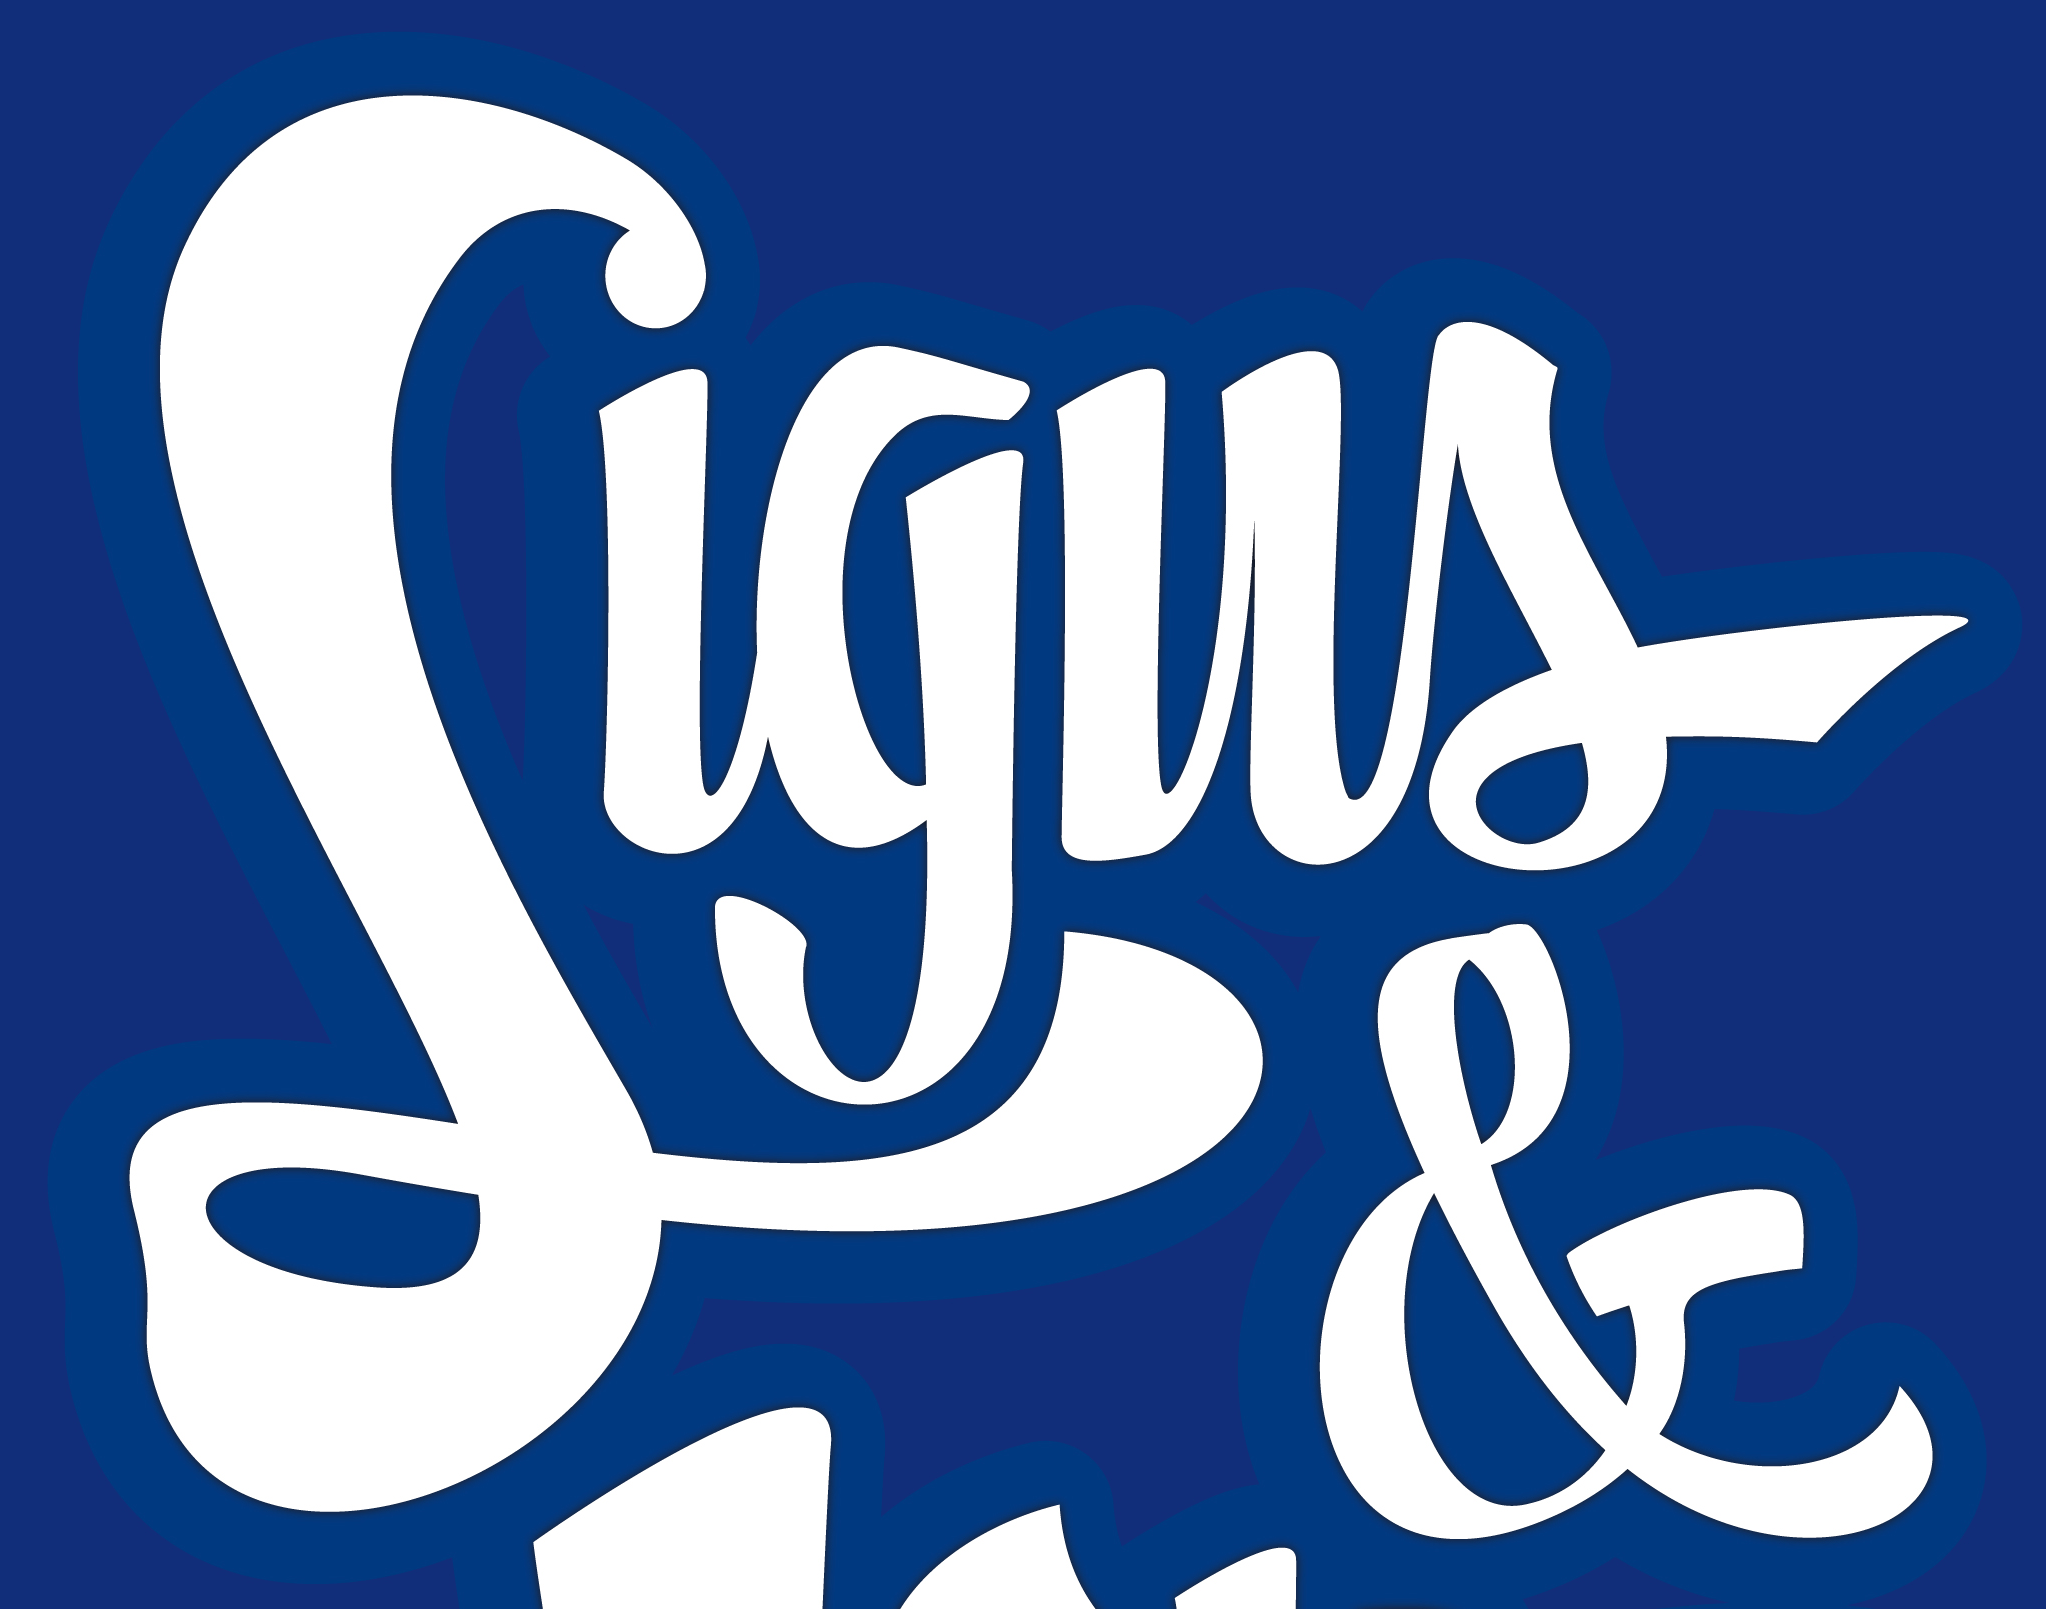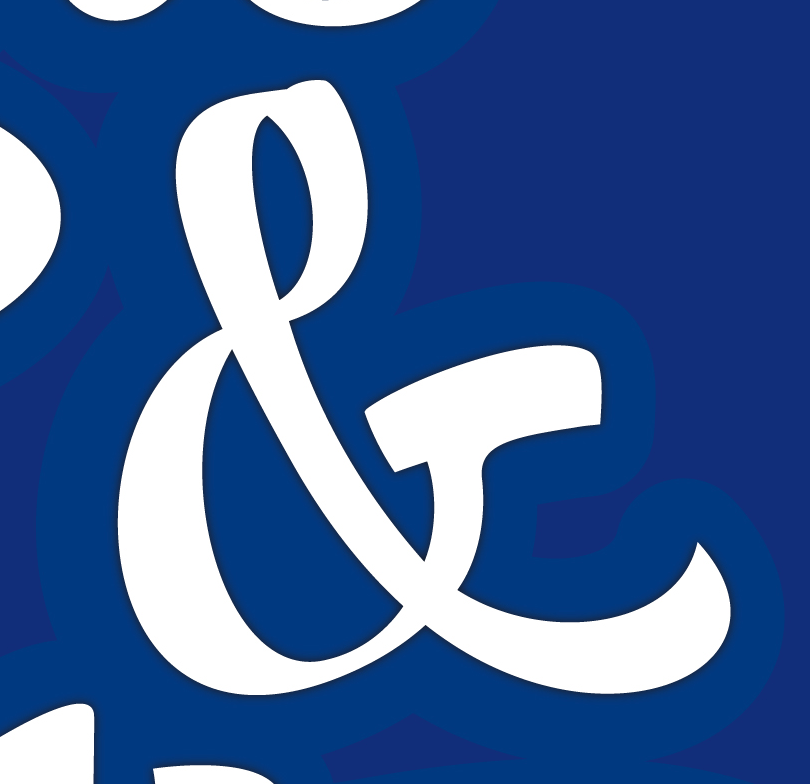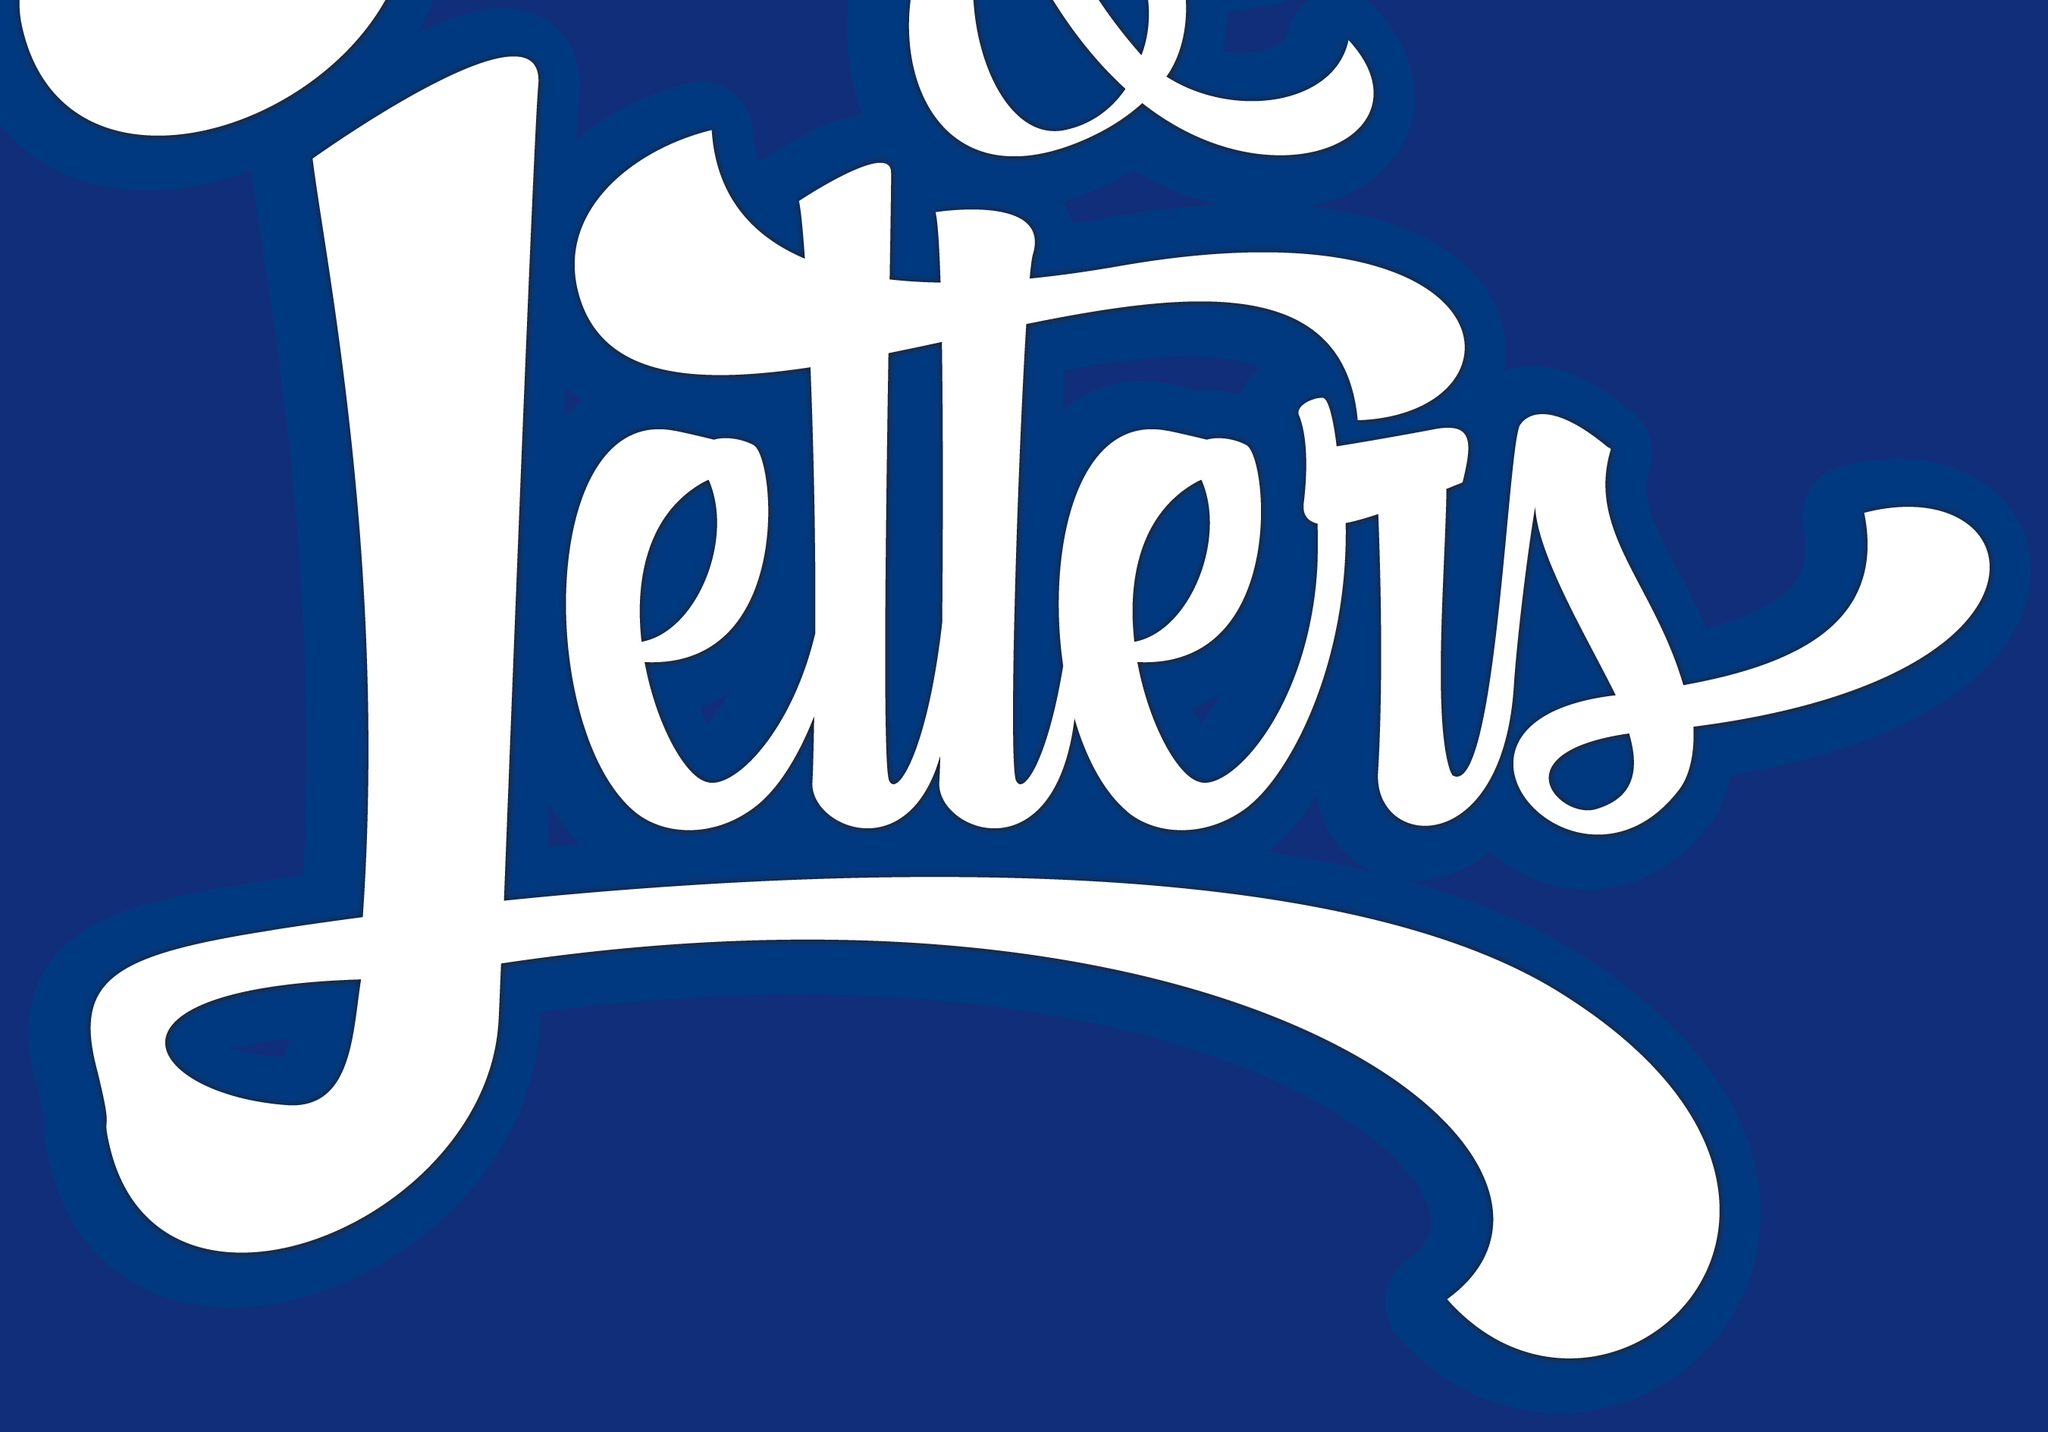What text is displayed in these images sequentially, separated by a semicolon? Signs; &; Letters 